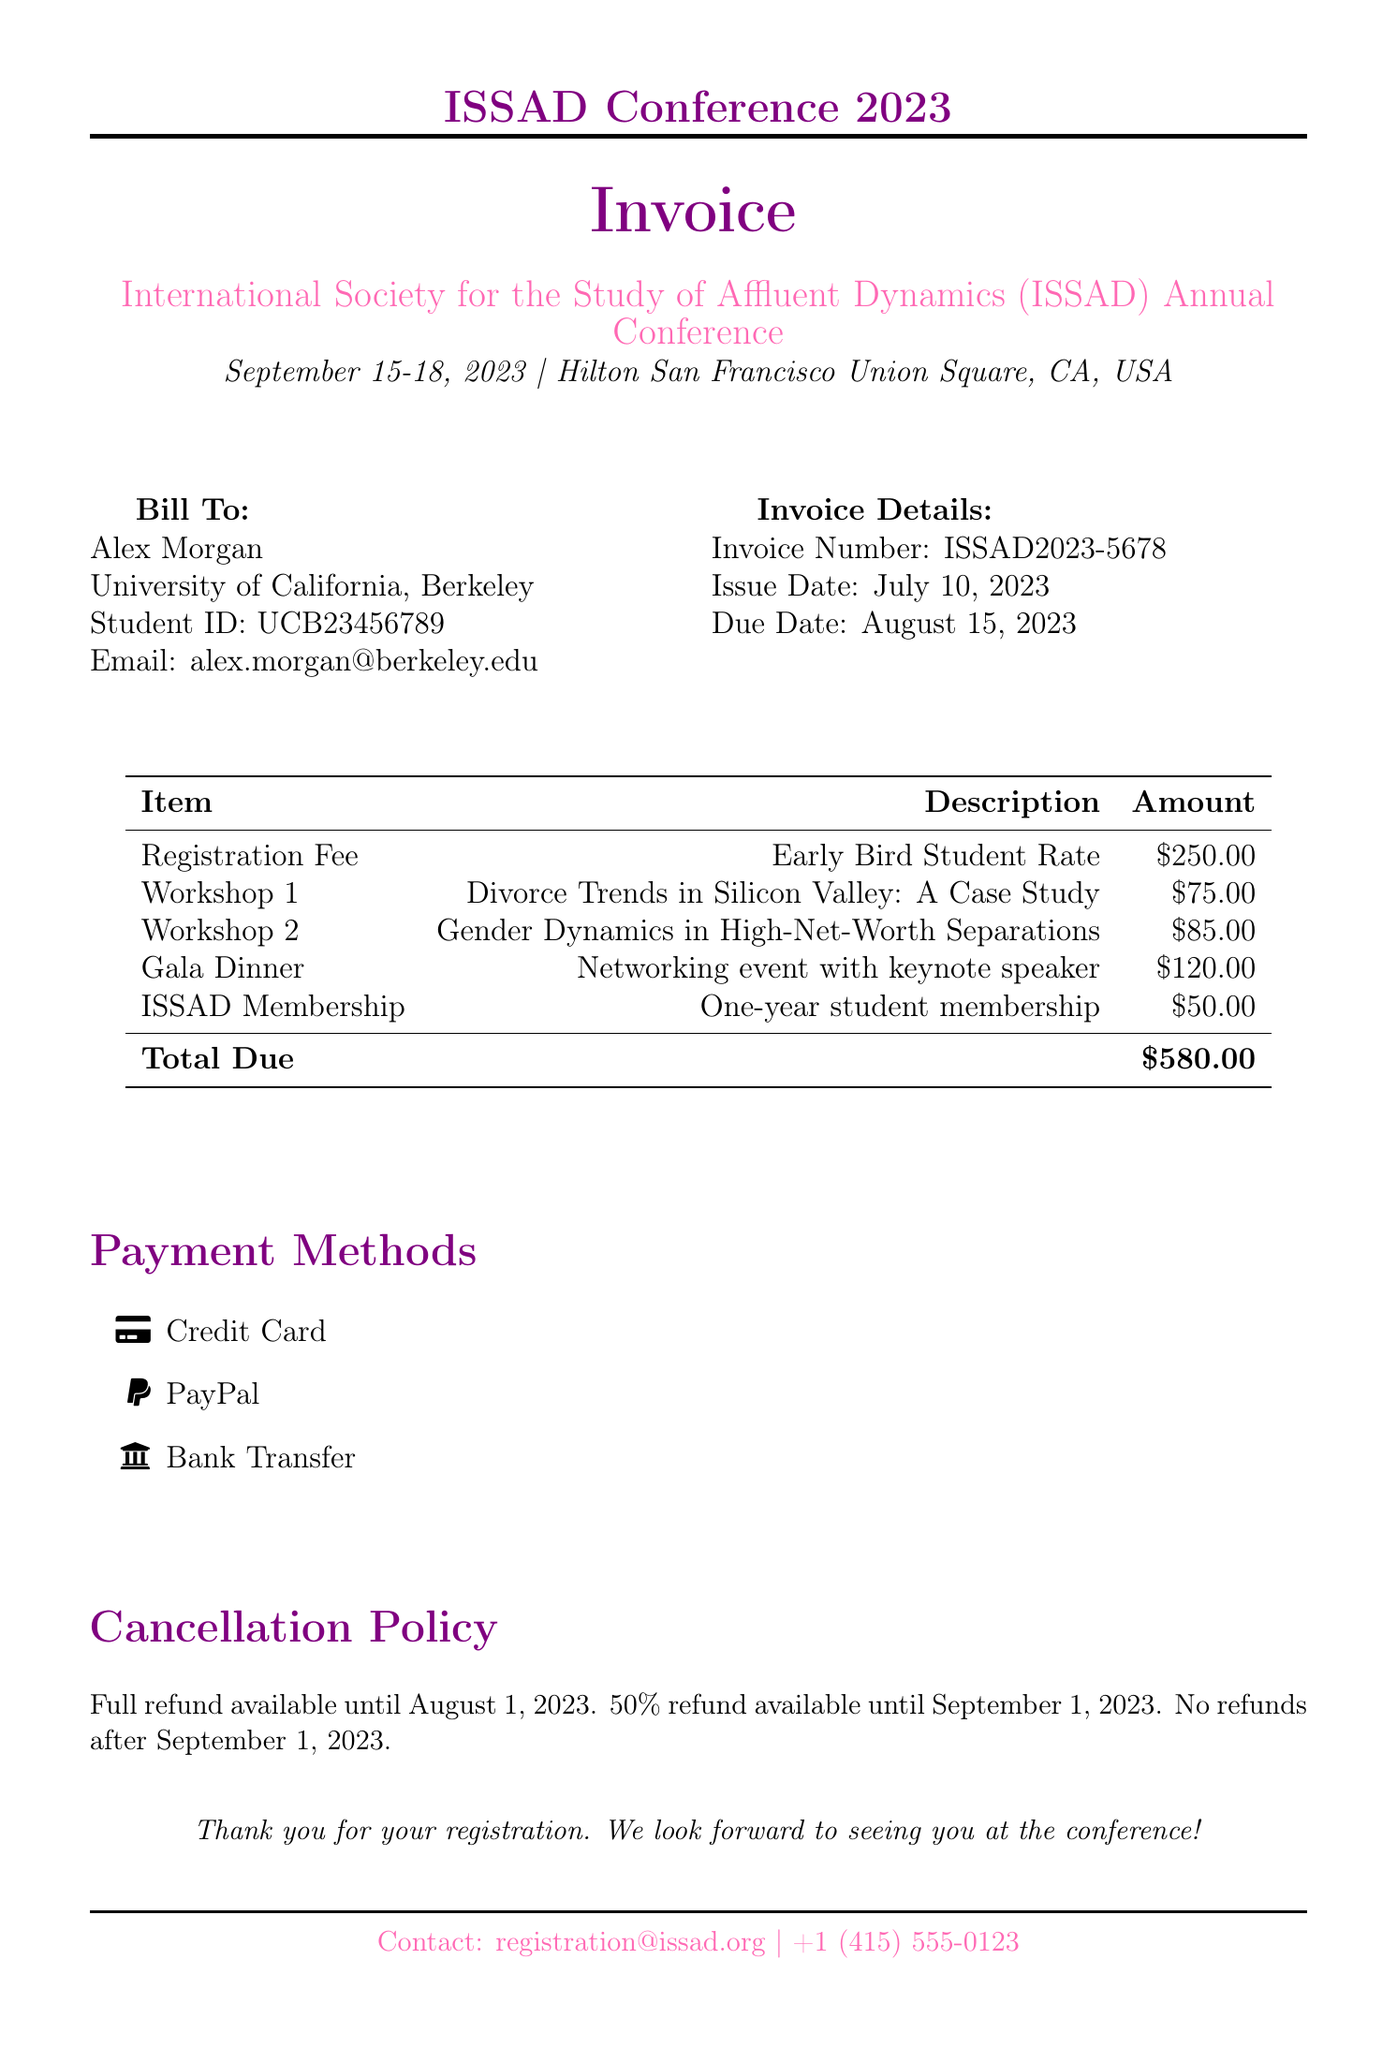What is the name of the conference? The name of the conference is stated at the top of the document.
Answer: International Society for the Study of Affluent Dynamics (ISSAD) Annual Conference What is the early bird student registration fee? The early bird student registration fee is listed in the document under registration fees.
Answer: $250.00 Who is the presenter for the workshop on divorce trends? The presenter's name for the specific workshop is provided under the workshop details.
Answer: Dr. Emily Chen, Stanford University What is the total amount due on the invoice? The total amount due is calculated and displayed at the bottom of the invoice table.
Answer: $580.00 When is the cancellation policy cut-off date for a full refund? The cut-off date for a full refund is mentioned in the cancellation policy section of the document.
Answer: August 1, 2023 What is the fee for the ISSAD student membership? The fee for the student membership is clearly stated in the additional items section.
Answer: $50.00 What date does the conference take place? The conference date is highlighted in the main conference details.
Answer: September 15-18, 2023 How can participants pay for the registration? The document lists available payment methods, indicating how participants can make their payment.
Answer: Credit Card, PayPal, Bank Transfer 